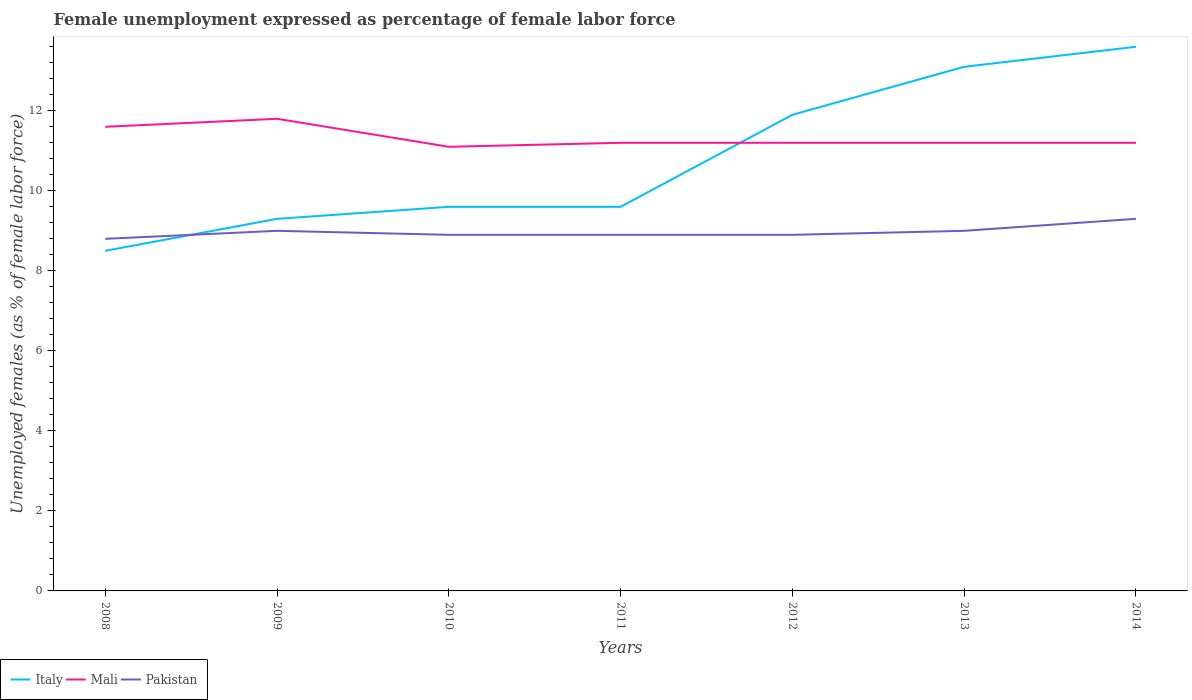How many different coloured lines are there?
Your answer should be compact. 3. Across all years, what is the maximum unemployment in females in in Pakistan?
Make the answer very short. 8.8. In which year was the unemployment in females in in Pakistan maximum?
Your response must be concise. 2008. What is the total unemployment in females in in Italy in the graph?
Provide a short and direct response. -0.3. What is the difference between the highest and the second highest unemployment in females in in Italy?
Your answer should be very brief. 5.1. How many lines are there?
Offer a very short reply. 3. How many years are there in the graph?
Provide a short and direct response. 7. Are the values on the major ticks of Y-axis written in scientific E-notation?
Ensure brevity in your answer.  No. Where does the legend appear in the graph?
Keep it short and to the point. Bottom left. What is the title of the graph?
Keep it short and to the point. Female unemployment expressed as percentage of female labor force. Does "Philippines" appear as one of the legend labels in the graph?
Give a very brief answer. No. What is the label or title of the X-axis?
Your answer should be very brief. Years. What is the label or title of the Y-axis?
Offer a very short reply. Unemployed females (as % of female labor force). What is the Unemployed females (as % of female labor force) of Italy in 2008?
Provide a short and direct response. 8.5. What is the Unemployed females (as % of female labor force) of Mali in 2008?
Ensure brevity in your answer.  11.6. What is the Unemployed females (as % of female labor force) of Pakistan in 2008?
Provide a succinct answer. 8.8. What is the Unemployed females (as % of female labor force) of Italy in 2009?
Your answer should be very brief. 9.3. What is the Unemployed females (as % of female labor force) of Mali in 2009?
Make the answer very short. 11.8. What is the Unemployed females (as % of female labor force) of Pakistan in 2009?
Make the answer very short. 9. What is the Unemployed females (as % of female labor force) in Italy in 2010?
Ensure brevity in your answer.  9.6. What is the Unemployed females (as % of female labor force) in Mali in 2010?
Your answer should be compact. 11.1. What is the Unemployed females (as % of female labor force) of Pakistan in 2010?
Make the answer very short. 8.9. What is the Unemployed females (as % of female labor force) in Italy in 2011?
Give a very brief answer. 9.6. What is the Unemployed females (as % of female labor force) in Mali in 2011?
Ensure brevity in your answer.  11.2. What is the Unemployed females (as % of female labor force) in Pakistan in 2011?
Your answer should be compact. 8.9. What is the Unemployed females (as % of female labor force) of Italy in 2012?
Make the answer very short. 11.9. What is the Unemployed females (as % of female labor force) in Mali in 2012?
Provide a short and direct response. 11.2. What is the Unemployed females (as % of female labor force) in Pakistan in 2012?
Ensure brevity in your answer.  8.9. What is the Unemployed females (as % of female labor force) in Italy in 2013?
Provide a short and direct response. 13.1. What is the Unemployed females (as % of female labor force) in Mali in 2013?
Offer a terse response. 11.2. What is the Unemployed females (as % of female labor force) of Italy in 2014?
Offer a very short reply. 13.6. What is the Unemployed females (as % of female labor force) in Mali in 2014?
Offer a terse response. 11.2. What is the Unemployed females (as % of female labor force) in Pakistan in 2014?
Make the answer very short. 9.3. Across all years, what is the maximum Unemployed females (as % of female labor force) of Italy?
Give a very brief answer. 13.6. Across all years, what is the maximum Unemployed females (as % of female labor force) of Mali?
Keep it short and to the point. 11.8. Across all years, what is the maximum Unemployed females (as % of female labor force) of Pakistan?
Provide a short and direct response. 9.3. Across all years, what is the minimum Unemployed females (as % of female labor force) of Mali?
Your answer should be very brief. 11.1. Across all years, what is the minimum Unemployed females (as % of female labor force) of Pakistan?
Make the answer very short. 8.8. What is the total Unemployed females (as % of female labor force) in Italy in the graph?
Offer a terse response. 75.6. What is the total Unemployed females (as % of female labor force) of Mali in the graph?
Your answer should be compact. 79.3. What is the total Unemployed females (as % of female labor force) of Pakistan in the graph?
Offer a very short reply. 62.8. What is the difference between the Unemployed females (as % of female labor force) of Italy in 2008 and that in 2010?
Provide a short and direct response. -1.1. What is the difference between the Unemployed females (as % of female labor force) in Mali in 2008 and that in 2010?
Your answer should be very brief. 0.5. What is the difference between the Unemployed females (as % of female labor force) of Italy in 2008 and that in 2011?
Provide a short and direct response. -1.1. What is the difference between the Unemployed females (as % of female labor force) in Mali in 2008 and that in 2011?
Provide a succinct answer. 0.4. What is the difference between the Unemployed females (as % of female labor force) of Pakistan in 2008 and that in 2011?
Keep it short and to the point. -0.1. What is the difference between the Unemployed females (as % of female labor force) in Mali in 2008 and that in 2012?
Your answer should be compact. 0.4. What is the difference between the Unemployed females (as % of female labor force) in Italy in 2008 and that in 2013?
Offer a terse response. -4.6. What is the difference between the Unemployed females (as % of female labor force) in Italy in 2008 and that in 2014?
Offer a terse response. -5.1. What is the difference between the Unemployed females (as % of female labor force) in Italy in 2009 and that in 2010?
Offer a terse response. -0.3. What is the difference between the Unemployed females (as % of female labor force) in Pakistan in 2009 and that in 2010?
Your response must be concise. 0.1. What is the difference between the Unemployed females (as % of female labor force) of Pakistan in 2009 and that in 2011?
Give a very brief answer. 0.1. What is the difference between the Unemployed females (as % of female labor force) of Italy in 2009 and that in 2014?
Keep it short and to the point. -4.3. What is the difference between the Unemployed females (as % of female labor force) of Mali in 2009 and that in 2014?
Your answer should be very brief. 0.6. What is the difference between the Unemployed females (as % of female labor force) in Pakistan in 2010 and that in 2011?
Offer a very short reply. 0. What is the difference between the Unemployed females (as % of female labor force) in Italy in 2010 and that in 2012?
Give a very brief answer. -2.3. What is the difference between the Unemployed females (as % of female labor force) in Mali in 2010 and that in 2012?
Your response must be concise. -0.1. What is the difference between the Unemployed females (as % of female labor force) of Pakistan in 2010 and that in 2012?
Make the answer very short. 0. What is the difference between the Unemployed females (as % of female labor force) of Italy in 2010 and that in 2013?
Make the answer very short. -3.5. What is the difference between the Unemployed females (as % of female labor force) of Mali in 2010 and that in 2013?
Make the answer very short. -0.1. What is the difference between the Unemployed females (as % of female labor force) in Italy in 2010 and that in 2014?
Make the answer very short. -4. What is the difference between the Unemployed females (as % of female labor force) in Italy in 2011 and that in 2012?
Give a very brief answer. -2.3. What is the difference between the Unemployed females (as % of female labor force) in Mali in 2011 and that in 2012?
Provide a succinct answer. 0. What is the difference between the Unemployed females (as % of female labor force) in Pakistan in 2011 and that in 2012?
Your answer should be compact. 0. What is the difference between the Unemployed females (as % of female labor force) in Italy in 2011 and that in 2013?
Ensure brevity in your answer.  -3.5. What is the difference between the Unemployed females (as % of female labor force) of Italy in 2011 and that in 2014?
Your answer should be compact. -4. What is the difference between the Unemployed females (as % of female labor force) in Pakistan in 2011 and that in 2014?
Offer a terse response. -0.4. What is the difference between the Unemployed females (as % of female labor force) of Mali in 2012 and that in 2013?
Provide a short and direct response. 0. What is the difference between the Unemployed females (as % of female labor force) of Italy in 2012 and that in 2014?
Provide a short and direct response. -1.7. What is the difference between the Unemployed females (as % of female labor force) of Mali in 2012 and that in 2014?
Make the answer very short. 0. What is the difference between the Unemployed females (as % of female labor force) of Pakistan in 2012 and that in 2014?
Your answer should be very brief. -0.4. What is the difference between the Unemployed females (as % of female labor force) of Italy in 2008 and the Unemployed females (as % of female labor force) of Mali in 2009?
Keep it short and to the point. -3.3. What is the difference between the Unemployed females (as % of female labor force) in Mali in 2008 and the Unemployed females (as % of female labor force) in Pakistan in 2009?
Keep it short and to the point. 2.6. What is the difference between the Unemployed females (as % of female labor force) of Mali in 2008 and the Unemployed females (as % of female labor force) of Pakistan in 2010?
Give a very brief answer. 2.7. What is the difference between the Unemployed females (as % of female labor force) in Italy in 2008 and the Unemployed females (as % of female labor force) in Mali in 2011?
Your answer should be very brief. -2.7. What is the difference between the Unemployed females (as % of female labor force) of Italy in 2008 and the Unemployed females (as % of female labor force) of Pakistan in 2011?
Provide a succinct answer. -0.4. What is the difference between the Unemployed females (as % of female labor force) in Mali in 2008 and the Unemployed females (as % of female labor force) in Pakistan in 2011?
Your answer should be compact. 2.7. What is the difference between the Unemployed females (as % of female labor force) of Italy in 2008 and the Unemployed females (as % of female labor force) of Pakistan in 2013?
Offer a very short reply. -0.5. What is the difference between the Unemployed females (as % of female labor force) of Italy in 2008 and the Unemployed females (as % of female labor force) of Pakistan in 2014?
Your answer should be compact. -0.8. What is the difference between the Unemployed females (as % of female labor force) of Italy in 2009 and the Unemployed females (as % of female labor force) of Pakistan in 2010?
Offer a very short reply. 0.4. What is the difference between the Unemployed females (as % of female labor force) in Italy in 2009 and the Unemployed females (as % of female labor force) in Mali in 2011?
Your answer should be compact. -1.9. What is the difference between the Unemployed females (as % of female labor force) of Mali in 2009 and the Unemployed females (as % of female labor force) of Pakistan in 2011?
Give a very brief answer. 2.9. What is the difference between the Unemployed females (as % of female labor force) of Mali in 2009 and the Unemployed females (as % of female labor force) of Pakistan in 2012?
Keep it short and to the point. 2.9. What is the difference between the Unemployed females (as % of female labor force) of Italy in 2009 and the Unemployed females (as % of female labor force) of Mali in 2013?
Make the answer very short. -1.9. What is the difference between the Unemployed females (as % of female labor force) of Italy in 2009 and the Unemployed females (as % of female labor force) of Pakistan in 2013?
Your answer should be compact. 0.3. What is the difference between the Unemployed females (as % of female labor force) in Mali in 2009 and the Unemployed females (as % of female labor force) in Pakistan in 2013?
Ensure brevity in your answer.  2.8. What is the difference between the Unemployed females (as % of female labor force) of Mali in 2009 and the Unemployed females (as % of female labor force) of Pakistan in 2014?
Give a very brief answer. 2.5. What is the difference between the Unemployed females (as % of female labor force) of Mali in 2010 and the Unemployed females (as % of female labor force) of Pakistan in 2011?
Your answer should be compact. 2.2. What is the difference between the Unemployed females (as % of female labor force) of Italy in 2010 and the Unemployed females (as % of female labor force) of Mali in 2012?
Your answer should be compact. -1.6. What is the difference between the Unemployed females (as % of female labor force) in Italy in 2010 and the Unemployed females (as % of female labor force) in Mali in 2013?
Give a very brief answer. -1.6. What is the difference between the Unemployed females (as % of female labor force) in Italy in 2010 and the Unemployed females (as % of female labor force) in Pakistan in 2013?
Provide a short and direct response. 0.6. What is the difference between the Unemployed females (as % of female labor force) of Italy in 2011 and the Unemployed females (as % of female labor force) of Mali in 2012?
Provide a succinct answer. -1.6. What is the difference between the Unemployed females (as % of female labor force) in Italy in 2011 and the Unemployed females (as % of female labor force) in Pakistan in 2013?
Your answer should be very brief. 0.6. What is the difference between the Unemployed females (as % of female labor force) of Mali in 2011 and the Unemployed females (as % of female labor force) of Pakistan in 2013?
Give a very brief answer. 2.2. What is the difference between the Unemployed females (as % of female labor force) of Italy in 2011 and the Unemployed females (as % of female labor force) of Pakistan in 2014?
Keep it short and to the point. 0.3. What is the difference between the Unemployed females (as % of female labor force) in Italy in 2012 and the Unemployed females (as % of female labor force) in Mali in 2013?
Provide a short and direct response. 0.7. What is the difference between the Unemployed females (as % of female labor force) of Italy in 2012 and the Unemployed females (as % of female labor force) of Pakistan in 2013?
Your response must be concise. 2.9. What is the difference between the Unemployed females (as % of female labor force) in Italy in 2012 and the Unemployed females (as % of female labor force) in Pakistan in 2014?
Provide a short and direct response. 2.6. What is the difference between the Unemployed females (as % of female labor force) in Italy in 2013 and the Unemployed females (as % of female labor force) in Mali in 2014?
Keep it short and to the point. 1.9. What is the difference between the Unemployed females (as % of female labor force) of Mali in 2013 and the Unemployed females (as % of female labor force) of Pakistan in 2014?
Offer a very short reply. 1.9. What is the average Unemployed females (as % of female labor force) of Italy per year?
Ensure brevity in your answer.  10.8. What is the average Unemployed females (as % of female labor force) in Mali per year?
Your answer should be compact. 11.33. What is the average Unemployed females (as % of female labor force) in Pakistan per year?
Keep it short and to the point. 8.97. In the year 2008, what is the difference between the Unemployed females (as % of female labor force) of Italy and Unemployed females (as % of female labor force) of Mali?
Provide a short and direct response. -3.1. In the year 2008, what is the difference between the Unemployed females (as % of female labor force) of Italy and Unemployed females (as % of female labor force) of Pakistan?
Offer a very short reply. -0.3. In the year 2008, what is the difference between the Unemployed females (as % of female labor force) in Mali and Unemployed females (as % of female labor force) in Pakistan?
Offer a terse response. 2.8. In the year 2009, what is the difference between the Unemployed females (as % of female labor force) of Italy and Unemployed females (as % of female labor force) of Mali?
Make the answer very short. -2.5. In the year 2009, what is the difference between the Unemployed females (as % of female labor force) of Italy and Unemployed females (as % of female labor force) of Pakistan?
Your answer should be very brief. 0.3. In the year 2009, what is the difference between the Unemployed females (as % of female labor force) in Mali and Unemployed females (as % of female labor force) in Pakistan?
Provide a succinct answer. 2.8. In the year 2012, what is the difference between the Unemployed females (as % of female labor force) of Italy and Unemployed females (as % of female labor force) of Mali?
Your answer should be compact. 0.7. In the year 2012, what is the difference between the Unemployed females (as % of female labor force) of Italy and Unemployed females (as % of female labor force) of Pakistan?
Your answer should be very brief. 3. In the year 2013, what is the difference between the Unemployed females (as % of female labor force) in Italy and Unemployed females (as % of female labor force) in Mali?
Keep it short and to the point. 1.9. In the year 2013, what is the difference between the Unemployed females (as % of female labor force) in Italy and Unemployed females (as % of female labor force) in Pakistan?
Give a very brief answer. 4.1. In the year 2014, what is the difference between the Unemployed females (as % of female labor force) in Italy and Unemployed females (as % of female labor force) in Mali?
Provide a short and direct response. 2.4. What is the ratio of the Unemployed females (as % of female labor force) in Italy in 2008 to that in 2009?
Ensure brevity in your answer.  0.91. What is the ratio of the Unemployed females (as % of female labor force) of Mali in 2008 to that in 2009?
Make the answer very short. 0.98. What is the ratio of the Unemployed females (as % of female labor force) in Pakistan in 2008 to that in 2009?
Keep it short and to the point. 0.98. What is the ratio of the Unemployed females (as % of female labor force) of Italy in 2008 to that in 2010?
Give a very brief answer. 0.89. What is the ratio of the Unemployed females (as % of female labor force) in Mali in 2008 to that in 2010?
Offer a terse response. 1.04. What is the ratio of the Unemployed females (as % of female labor force) of Italy in 2008 to that in 2011?
Make the answer very short. 0.89. What is the ratio of the Unemployed females (as % of female labor force) in Mali in 2008 to that in 2011?
Provide a short and direct response. 1.04. What is the ratio of the Unemployed females (as % of female labor force) in Mali in 2008 to that in 2012?
Your response must be concise. 1.04. What is the ratio of the Unemployed females (as % of female labor force) of Italy in 2008 to that in 2013?
Offer a terse response. 0.65. What is the ratio of the Unemployed females (as % of female labor force) in Mali in 2008 to that in 2013?
Provide a short and direct response. 1.04. What is the ratio of the Unemployed females (as % of female labor force) in Pakistan in 2008 to that in 2013?
Provide a short and direct response. 0.98. What is the ratio of the Unemployed females (as % of female labor force) of Italy in 2008 to that in 2014?
Your answer should be compact. 0.62. What is the ratio of the Unemployed females (as % of female labor force) of Mali in 2008 to that in 2014?
Offer a very short reply. 1.04. What is the ratio of the Unemployed females (as % of female labor force) of Pakistan in 2008 to that in 2014?
Offer a very short reply. 0.95. What is the ratio of the Unemployed females (as % of female labor force) in Italy in 2009 to that in 2010?
Provide a short and direct response. 0.97. What is the ratio of the Unemployed females (as % of female labor force) in Mali in 2009 to that in 2010?
Offer a very short reply. 1.06. What is the ratio of the Unemployed females (as % of female labor force) of Pakistan in 2009 to that in 2010?
Your answer should be very brief. 1.01. What is the ratio of the Unemployed females (as % of female labor force) of Italy in 2009 to that in 2011?
Offer a very short reply. 0.97. What is the ratio of the Unemployed females (as % of female labor force) of Mali in 2009 to that in 2011?
Ensure brevity in your answer.  1.05. What is the ratio of the Unemployed females (as % of female labor force) in Pakistan in 2009 to that in 2011?
Ensure brevity in your answer.  1.01. What is the ratio of the Unemployed females (as % of female labor force) in Italy in 2009 to that in 2012?
Provide a succinct answer. 0.78. What is the ratio of the Unemployed females (as % of female labor force) in Mali in 2009 to that in 2012?
Provide a short and direct response. 1.05. What is the ratio of the Unemployed females (as % of female labor force) in Pakistan in 2009 to that in 2012?
Your response must be concise. 1.01. What is the ratio of the Unemployed females (as % of female labor force) in Italy in 2009 to that in 2013?
Ensure brevity in your answer.  0.71. What is the ratio of the Unemployed females (as % of female labor force) of Mali in 2009 to that in 2013?
Offer a very short reply. 1.05. What is the ratio of the Unemployed females (as % of female labor force) of Pakistan in 2009 to that in 2013?
Your answer should be compact. 1. What is the ratio of the Unemployed females (as % of female labor force) in Italy in 2009 to that in 2014?
Give a very brief answer. 0.68. What is the ratio of the Unemployed females (as % of female labor force) in Mali in 2009 to that in 2014?
Provide a short and direct response. 1.05. What is the ratio of the Unemployed females (as % of female labor force) of Pakistan in 2009 to that in 2014?
Offer a terse response. 0.97. What is the ratio of the Unemployed females (as % of female labor force) of Pakistan in 2010 to that in 2011?
Make the answer very short. 1. What is the ratio of the Unemployed females (as % of female labor force) in Italy in 2010 to that in 2012?
Give a very brief answer. 0.81. What is the ratio of the Unemployed females (as % of female labor force) in Italy in 2010 to that in 2013?
Keep it short and to the point. 0.73. What is the ratio of the Unemployed females (as % of female labor force) in Mali in 2010 to that in 2013?
Offer a very short reply. 0.99. What is the ratio of the Unemployed females (as % of female labor force) of Pakistan in 2010 to that in 2013?
Ensure brevity in your answer.  0.99. What is the ratio of the Unemployed females (as % of female labor force) in Italy in 2010 to that in 2014?
Provide a short and direct response. 0.71. What is the ratio of the Unemployed females (as % of female labor force) in Mali in 2010 to that in 2014?
Give a very brief answer. 0.99. What is the ratio of the Unemployed females (as % of female labor force) of Italy in 2011 to that in 2012?
Your response must be concise. 0.81. What is the ratio of the Unemployed females (as % of female labor force) in Mali in 2011 to that in 2012?
Ensure brevity in your answer.  1. What is the ratio of the Unemployed females (as % of female labor force) of Pakistan in 2011 to that in 2012?
Offer a terse response. 1. What is the ratio of the Unemployed females (as % of female labor force) of Italy in 2011 to that in 2013?
Your response must be concise. 0.73. What is the ratio of the Unemployed females (as % of female labor force) in Pakistan in 2011 to that in 2013?
Provide a short and direct response. 0.99. What is the ratio of the Unemployed females (as % of female labor force) of Italy in 2011 to that in 2014?
Give a very brief answer. 0.71. What is the ratio of the Unemployed females (as % of female labor force) of Mali in 2011 to that in 2014?
Offer a very short reply. 1. What is the ratio of the Unemployed females (as % of female labor force) in Italy in 2012 to that in 2013?
Your answer should be compact. 0.91. What is the ratio of the Unemployed females (as % of female labor force) of Mali in 2012 to that in 2013?
Provide a succinct answer. 1. What is the ratio of the Unemployed females (as % of female labor force) in Pakistan in 2012 to that in 2013?
Your response must be concise. 0.99. What is the ratio of the Unemployed females (as % of female labor force) in Mali in 2012 to that in 2014?
Your response must be concise. 1. What is the ratio of the Unemployed females (as % of female labor force) in Pakistan in 2012 to that in 2014?
Make the answer very short. 0.96. What is the ratio of the Unemployed females (as % of female labor force) of Italy in 2013 to that in 2014?
Give a very brief answer. 0.96. What is the ratio of the Unemployed females (as % of female labor force) of Pakistan in 2013 to that in 2014?
Keep it short and to the point. 0.97. What is the difference between the highest and the second highest Unemployed females (as % of female labor force) of Pakistan?
Offer a very short reply. 0.3. What is the difference between the highest and the lowest Unemployed females (as % of female labor force) in Italy?
Make the answer very short. 5.1. What is the difference between the highest and the lowest Unemployed females (as % of female labor force) of Mali?
Make the answer very short. 0.7. 